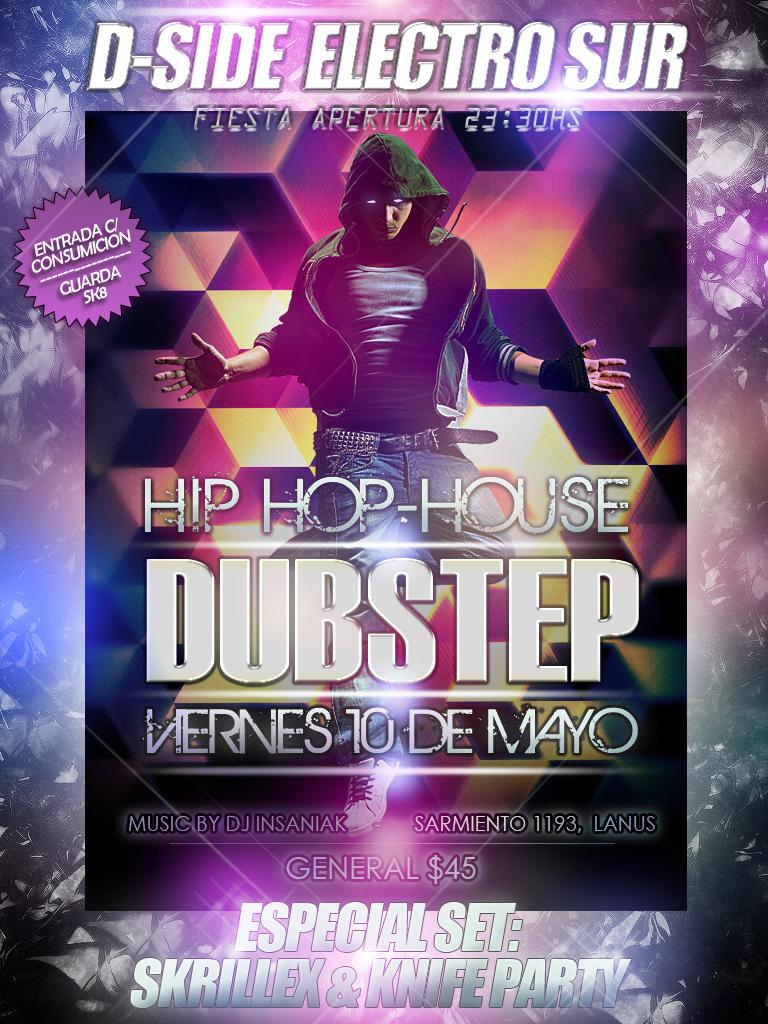How much does general admission cost?
Your response must be concise. 45. 